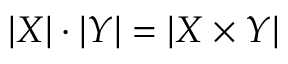Convert formula to latex. <formula><loc_0><loc_0><loc_500><loc_500>| X | \cdot | Y | = | X \times Y |</formula> 